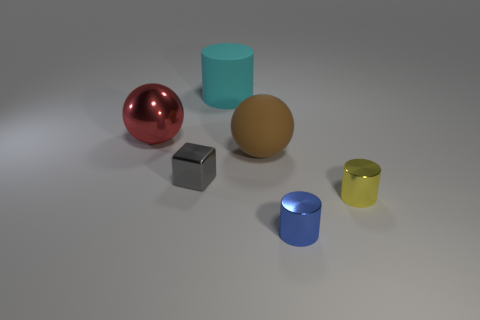How many other objects are the same color as the shiny sphere?
Your answer should be compact. 0. What is the size of the sphere that is to the left of the cylinder behind the small gray object?
Ensure brevity in your answer.  Large. Are the big ball that is on the left side of the large cyan rubber cylinder and the large brown thing made of the same material?
Your answer should be compact. No. What shape is the object to the left of the gray object?
Offer a very short reply. Sphere. How many yellow metallic objects have the same size as the blue object?
Provide a short and direct response. 1. The red metallic sphere is what size?
Your answer should be very brief. Large. There is a large rubber cylinder; what number of matte things are in front of it?
Provide a succinct answer. 1. The big cyan object that is the same material as the brown object is what shape?
Ensure brevity in your answer.  Cylinder. Is the number of large cyan rubber things that are on the right side of the big rubber sphere less than the number of tiny gray cubes that are on the right side of the tiny gray shiny block?
Offer a terse response. No. Is the number of yellow metallic cylinders greater than the number of small green rubber blocks?
Your response must be concise. Yes. 